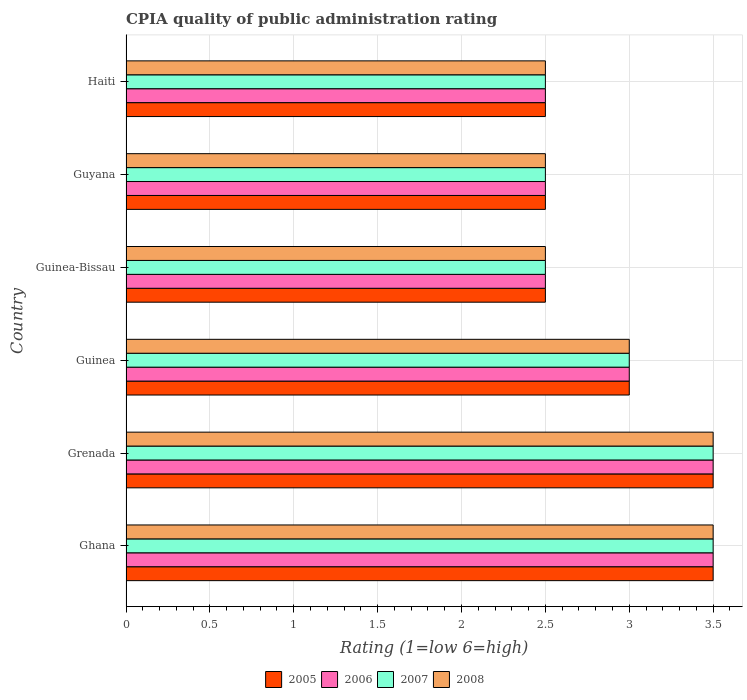How many different coloured bars are there?
Provide a short and direct response. 4. Are the number of bars on each tick of the Y-axis equal?
Your response must be concise. Yes. How many bars are there on the 1st tick from the bottom?
Provide a succinct answer. 4. What is the label of the 3rd group of bars from the top?
Make the answer very short. Guinea-Bissau. In how many cases, is the number of bars for a given country not equal to the number of legend labels?
Offer a terse response. 0. Across all countries, what is the maximum CPIA rating in 2008?
Give a very brief answer. 3.5. Across all countries, what is the minimum CPIA rating in 2007?
Offer a terse response. 2.5. In which country was the CPIA rating in 2007 maximum?
Keep it short and to the point. Ghana. In which country was the CPIA rating in 2008 minimum?
Ensure brevity in your answer.  Guinea-Bissau. What is the difference between the CPIA rating in 2007 in Ghana and the CPIA rating in 2008 in Guyana?
Offer a very short reply. 1. What is the average CPIA rating in 2005 per country?
Provide a short and direct response. 2.92. In how many countries, is the CPIA rating in 2005 greater than 2.2 ?
Offer a very short reply. 6. What is the ratio of the CPIA rating in 2006 in Ghana to that in Guinea-Bissau?
Provide a short and direct response. 1.4. Is the CPIA rating in 2007 in Grenada less than that in Guyana?
Your answer should be very brief. No. Is the difference between the CPIA rating in 2005 in Guyana and Haiti greater than the difference between the CPIA rating in 2006 in Guyana and Haiti?
Provide a succinct answer. No. What is the difference between the highest and the second highest CPIA rating in 2008?
Keep it short and to the point. 0. What is the difference between the highest and the lowest CPIA rating in 2008?
Keep it short and to the point. 1. Is it the case that in every country, the sum of the CPIA rating in 2005 and CPIA rating in 2008 is greater than the sum of CPIA rating in 2007 and CPIA rating in 2006?
Make the answer very short. No. What does the 4th bar from the top in Grenada represents?
Your answer should be very brief. 2005. What does the 4th bar from the bottom in Grenada represents?
Provide a short and direct response. 2008. Is it the case that in every country, the sum of the CPIA rating in 2005 and CPIA rating in 2006 is greater than the CPIA rating in 2008?
Ensure brevity in your answer.  Yes. How many bars are there?
Keep it short and to the point. 24. What is the difference between two consecutive major ticks on the X-axis?
Make the answer very short. 0.5. Does the graph contain grids?
Ensure brevity in your answer.  Yes. Where does the legend appear in the graph?
Give a very brief answer. Bottom center. How many legend labels are there?
Your response must be concise. 4. How are the legend labels stacked?
Keep it short and to the point. Horizontal. What is the title of the graph?
Your answer should be very brief. CPIA quality of public administration rating. Does "2005" appear as one of the legend labels in the graph?
Ensure brevity in your answer.  Yes. What is the label or title of the X-axis?
Ensure brevity in your answer.  Rating (1=low 6=high). What is the label or title of the Y-axis?
Offer a very short reply. Country. What is the Rating (1=low 6=high) of 2005 in Ghana?
Keep it short and to the point. 3.5. What is the Rating (1=low 6=high) in 2008 in Ghana?
Keep it short and to the point. 3.5. What is the Rating (1=low 6=high) in 2006 in Grenada?
Give a very brief answer. 3.5. What is the Rating (1=low 6=high) of 2008 in Guinea?
Offer a very short reply. 3. What is the Rating (1=low 6=high) in 2005 in Guinea-Bissau?
Provide a short and direct response. 2.5. What is the Rating (1=low 6=high) of 2006 in Guinea-Bissau?
Give a very brief answer. 2.5. What is the Rating (1=low 6=high) in 2007 in Guinea-Bissau?
Give a very brief answer. 2.5. What is the Rating (1=low 6=high) in 2006 in Guyana?
Make the answer very short. 2.5. What is the Rating (1=low 6=high) of 2008 in Guyana?
Offer a very short reply. 2.5. What is the Rating (1=low 6=high) in 2006 in Haiti?
Keep it short and to the point. 2.5. What is the Rating (1=low 6=high) in 2007 in Haiti?
Make the answer very short. 2.5. Across all countries, what is the maximum Rating (1=low 6=high) in 2006?
Your answer should be compact. 3.5. Across all countries, what is the maximum Rating (1=low 6=high) in 2008?
Make the answer very short. 3.5. Across all countries, what is the minimum Rating (1=low 6=high) in 2008?
Ensure brevity in your answer.  2.5. What is the total Rating (1=low 6=high) of 2005 in the graph?
Your response must be concise. 17.5. What is the total Rating (1=low 6=high) in 2007 in the graph?
Offer a terse response. 17.5. What is the total Rating (1=low 6=high) in 2008 in the graph?
Your answer should be very brief. 17.5. What is the difference between the Rating (1=low 6=high) in 2007 in Ghana and that in Grenada?
Offer a very short reply. 0. What is the difference between the Rating (1=low 6=high) of 2008 in Ghana and that in Grenada?
Keep it short and to the point. 0. What is the difference between the Rating (1=low 6=high) of 2005 in Ghana and that in Guinea?
Provide a short and direct response. 0.5. What is the difference between the Rating (1=low 6=high) in 2006 in Ghana and that in Guinea?
Your answer should be very brief. 0.5. What is the difference between the Rating (1=low 6=high) of 2005 in Ghana and that in Guinea-Bissau?
Give a very brief answer. 1. What is the difference between the Rating (1=low 6=high) of 2006 in Ghana and that in Guinea-Bissau?
Your response must be concise. 1. What is the difference between the Rating (1=low 6=high) in 2005 in Ghana and that in Guyana?
Make the answer very short. 1. What is the difference between the Rating (1=low 6=high) of 2006 in Ghana and that in Guyana?
Make the answer very short. 1. What is the difference between the Rating (1=low 6=high) of 2008 in Ghana and that in Guyana?
Keep it short and to the point. 1. What is the difference between the Rating (1=low 6=high) of 2006 in Ghana and that in Haiti?
Your answer should be compact. 1. What is the difference between the Rating (1=low 6=high) of 2008 in Ghana and that in Haiti?
Give a very brief answer. 1. What is the difference between the Rating (1=low 6=high) of 2005 in Grenada and that in Guinea?
Give a very brief answer. 0.5. What is the difference between the Rating (1=low 6=high) of 2007 in Grenada and that in Guinea-Bissau?
Ensure brevity in your answer.  1. What is the difference between the Rating (1=low 6=high) in 2008 in Grenada and that in Guyana?
Ensure brevity in your answer.  1. What is the difference between the Rating (1=low 6=high) in 2006 in Grenada and that in Haiti?
Offer a terse response. 1. What is the difference between the Rating (1=low 6=high) of 2005 in Guinea and that in Guinea-Bissau?
Provide a succinct answer. 0.5. What is the difference between the Rating (1=low 6=high) in 2006 in Guinea and that in Guyana?
Your response must be concise. 0.5. What is the difference between the Rating (1=low 6=high) of 2008 in Guinea and that in Guyana?
Your answer should be compact. 0.5. What is the difference between the Rating (1=low 6=high) in 2006 in Guinea and that in Haiti?
Your answer should be compact. 0.5. What is the difference between the Rating (1=low 6=high) in 2005 in Guinea-Bissau and that in Guyana?
Your answer should be very brief. 0. What is the difference between the Rating (1=low 6=high) of 2006 in Guinea-Bissau and that in Guyana?
Offer a terse response. 0. What is the difference between the Rating (1=low 6=high) of 2008 in Guinea-Bissau and that in Guyana?
Your answer should be very brief. 0. What is the difference between the Rating (1=low 6=high) in 2005 in Guinea-Bissau and that in Haiti?
Make the answer very short. 0. What is the difference between the Rating (1=low 6=high) in 2006 in Guinea-Bissau and that in Haiti?
Provide a succinct answer. 0. What is the difference between the Rating (1=low 6=high) in 2006 in Guyana and that in Haiti?
Your answer should be very brief. 0. What is the difference between the Rating (1=low 6=high) of 2007 in Guyana and that in Haiti?
Give a very brief answer. 0. What is the difference between the Rating (1=low 6=high) in 2008 in Guyana and that in Haiti?
Provide a succinct answer. 0. What is the difference between the Rating (1=low 6=high) in 2005 in Ghana and the Rating (1=low 6=high) in 2007 in Grenada?
Give a very brief answer. 0. What is the difference between the Rating (1=low 6=high) of 2005 in Ghana and the Rating (1=low 6=high) of 2008 in Grenada?
Offer a very short reply. 0. What is the difference between the Rating (1=low 6=high) of 2006 in Ghana and the Rating (1=low 6=high) of 2007 in Grenada?
Provide a short and direct response. 0. What is the difference between the Rating (1=low 6=high) of 2005 in Ghana and the Rating (1=low 6=high) of 2006 in Guinea?
Your answer should be very brief. 0.5. What is the difference between the Rating (1=low 6=high) of 2005 in Ghana and the Rating (1=low 6=high) of 2007 in Guinea?
Your answer should be compact. 0.5. What is the difference between the Rating (1=low 6=high) in 2005 in Ghana and the Rating (1=low 6=high) in 2008 in Guinea?
Your answer should be very brief. 0.5. What is the difference between the Rating (1=low 6=high) of 2006 in Ghana and the Rating (1=low 6=high) of 2007 in Guinea?
Ensure brevity in your answer.  0.5. What is the difference between the Rating (1=low 6=high) in 2006 in Ghana and the Rating (1=low 6=high) in 2008 in Guinea?
Give a very brief answer. 0.5. What is the difference between the Rating (1=low 6=high) of 2007 in Ghana and the Rating (1=low 6=high) of 2008 in Guinea?
Provide a short and direct response. 0.5. What is the difference between the Rating (1=low 6=high) of 2005 in Ghana and the Rating (1=low 6=high) of 2006 in Guinea-Bissau?
Ensure brevity in your answer.  1. What is the difference between the Rating (1=low 6=high) in 2005 in Ghana and the Rating (1=low 6=high) in 2006 in Guyana?
Keep it short and to the point. 1. What is the difference between the Rating (1=low 6=high) of 2005 in Ghana and the Rating (1=low 6=high) of 2007 in Guyana?
Offer a very short reply. 1. What is the difference between the Rating (1=low 6=high) in 2005 in Ghana and the Rating (1=low 6=high) in 2008 in Guyana?
Provide a succinct answer. 1. What is the difference between the Rating (1=low 6=high) of 2007 in Ghana and the Rating (1=low 6=high) of 2008 in Guyana?
Provide a short and direct response. 1. What is the difference between the Rating (1=low 6=high) in 2005 in Ghana and the Rating (1=low 6=high) in 2007 in Haiti?
Your answer should be compact. 1. What is the difference between the Rating (1=low 6=high) in 2005 in Ghana and the Rating (1=low 6=high) in 2008 in Haiti?
Provide a short and direct response. 1. What is the difference between the Rating (1=low 6=high) in 2006 in Ghana and the Rating (1=low 6=high) in 2007 in Haiti?
Give a very brief answer. 1. What is the difference between the Rating (1=low 6=high) in 2006 in Ghana and the Rating (1=low 6=high) in 2008 in Haiti?
Make the answer very short. 1. What is the difference between the Rating (1=low 6=high) of 2007 in Grenada and the Rating (1=low 6=high) of 2008 in Guinea?
Provide a succinct answer. 0.5. What is the difference between the Rating (1=low 6=high) of 2005 in Grenada and the Rating (1=low 6=high) of 2006 in Guinea-Bissau?
Offer a terse response. 1. What is the difference between the Rating (1=low 6=high) of 2007 in Grenada and the Rating (1=low 6=high) of 2008 in Guinea-Bissau?
Offer a very short reply. 1. What is the difference between the Rating (1=low 6=high) of 2005 in Grenada and the Rating (1=low 6=high) of 2006 in Guyana?
Keep it short and to the point. 1. What is the difference between the Rating (1=low 6=high) of 2007 in Grenada and the Rating (1=low 6=high) of 2008 in Guyana?
Provide a succinct answer. 1. What is the difference between the Rating (1=low 6=high) of 2005 in Grenada and the Rating (1=low 6=high) of 2006 in Haiti?
Provide a succinct answer. 1. What is the difference between the Rating (1=low 6=high) in 2005 in Grenada and the Rating (1=low 6=high) in 2008 in Haiti?
Ensure brevity in your answer.  1. What is the difference between the Rating (1=low 6=high) in 2007 in Grenada and the Rating (1=low 6=high) in 2008 in Haiti?
Offer a terse response. 1. What is the difference between the Rating (1=low 6=high) in 2005 in Guinea and the Rating (1=low 6=high) in 2008 in Guinea-Bissau?
Provide a short and direct response. 0.5. What is the difference between the Rating (1=low 6=high) in 2006 in Guinea and the Rating (1=low 6=high) in 2008 in Guinea-Bissau?
Provide a short and direct response. 0.5. What is the difference between the Rating (1=low 6=high) of 2005 in Guinea and the Rating (1=low 6=high) of 2006 in Guyana?
Your answer should be compact. 0.5. What is the difference between the Rating (1=low 6=high) in 2007 in Guinea and the Rating (1=low 6=high) in 2008 in Guyana?
Make the answer very short. 0.5. What is the difference between the Rating (1=low 6=high) of 2005 in Guinea and the Rating (1=low 6=high) of 2008 in Haiti?
Your answer should be compact. 0.5. What is the difference between the Rating (1=low 6=high) of 2006 in Guinea and the Rating (1=low 6=high) of 2008 in Haiti?
Provide a succinct answer. 0.5. What is the difference between the Rating (1=low 6=high) of 2005 in Guinea-Bissau and the Rating (1=low 6=high) of 2006 in Guyana?
Keep it short and to the point. 0. What is the difference between the Rating (1=low 6=high) of 2005 in Guinea-Bissau and the Rating (1=low 6=high) of 2007 in Guyana?
Provide a succinct answer. 0. What is the difference between the Rating (1=low 6=high) in 2005 in Guinea-Bissau and the Rating (1=low 6=high) in 2008 in Guyana?
Provide a short and direct response. 0. What is the difference between the Rating (1=low 6=high) of 2006 in Guinea-Bissau and the Rating (1=low 6=high) of 2007 in Guyana?
Make the answer very short. 0. What is the difference between the Rating (1=low 6=high) in 2006 in Guinea-Bissau and the Rating (1=low 6=high) in 2008 in Guyana?
Your answer should be very brief. 0. What is the difference between the Rating (1=low 6=high) of 2007 in Guinea-Bissau and the Rating (1=low 6=high) of 2008 in Guyana?
Your response must be concise. 0. What is the difference between the Rating (1=low 6=high) of 2005 in Guinea-Bissau and the Rating (1=low 6=high) of 2008 in Haiti?
Keep it short and to the point. 0. What is the difference between the Rating (1=low 6=high) in 2006 in Guinea-Bissau and the Rating (1=low 6=high) in 2007 in Haiti?
Make the answer very short. 0. What is the difference between the Rating (1=low 6=high) of 2007 in Guinea-Bissau and the Rating (1=low 6=high) of 2008 in Haiti?
Offer a terse response. 0. What is the difference between the Rating (1=low 6=high) in 2005 in Guyana and the Rating (1=low 6=high) in 2007 in Haiti?
Offer a terse response. 0. What is the difference between the Rating (1=low 6=high) in 2006 in Guyana and the Rating (1=low 6=high) in 2007 in Haiti?
Your answer should be compact. 0. What is the average Rating (1=low 6=high) in 2005 per country?
Provide a short and direct response. 2.92. What is the average Rating (1=low 6=high) in 2006 per country?
Keep it short and to the point. 2.92. What is the average Rating (1=low 6=high) of 2007 per country?
Provide a short and direct response. 2.92. What is the average Rating (1=low 6=high) of 2008 per country?
Give a very brief answer. 2.92. What is the difference between the Rating (1=low 6=high) of 2005 and Rating (1=low 6=high) of 2007 in Ghana?
Give a very brief answer. 0. What is the difference between the Rating (1=low 6=high) of 2005 and Rating (1=low 6=high) of 2008 in Ghana?
Provide a short and direct response. 0. What is the difference between the Rating (1=low 6=high) of 2005 and Rating (1=low 6=high) of 2007 in Grenada?
Ensure brevity in your answer.  0. What is the difference between the Rating (1=low 6=high) in 2005 and Rating (1=low 6=high) in 2008 in Grenada?
Your answer should be compact. 0. What is the difference between the Rating (1=low 6=high) of 2006 and Rating (1=low 6=high) of 2008 in Grenada?
Keep it short and to the point. 0. What is the difference between the Rating (1=low 6=high) in 2007 and Rating (1=low 6=high) in 2008 in Grenada?
Provide a short and direct response. 0. What is the difference between the Rating (1=low 6=high) in 2006 and Rating (1=low 6=high) in 2008 in Guinea?
Your answer should be compact. 0. What is the difference between the Rating (1=low 6=high) of 2005 and Rating (1=low 6=high) of 2006 in Guinea-Bissau?
Your response must be concise. 0. What is the difference between the Rating (1=low 6=high) of 2005 and Rating (1=low 6=high) of 2007 in Guinea-Bissau?
Ensure brevity in your answer.  0. What is the difference between the Rating (1=low 6=high) in 2007 and Rating (1=low 6=high) in 2008 in Guinea-Bissau?
Give a very brief answer. 0. What is the difference between the Rating (1=low 6=high) of 2005 and Rating (1=low 6=high) of 2006 in Guyana?
Your answer should be very brief. 0. What is the difference between the Rating (1=low 6=high) in 2006 and Rating (1=low 6=high) in 2007 in Guyana?
Your response must be concise. 0. What is the difference between the Rating (1=low 6=high) of 2006 and Rating (1=low 6=high) of 2008 in Guyana?
Give a very brief answer. 0. What is the difference between the Rating (1=low 6=high) of 2007 and Rating (1=low 6=high) of 2008 in Guyana?
Keep it short and to the point. 0. What is the difference between the Rating (1=low 6=high) of 2006 and Rating (1=low 6=high) of 2007 in Haiti?
Make the answer very short. 0. What is the ratio of the Rating (1=low 6=high) of 2005 in Ghana to that in Grenada?
Offer a very short reply. 1. What is the ratio of the Rating (1=low 6=high) of 2006 in Ghana to that in Grenada?
Provide a succinct answer. 1. What is the ratio of the Rating (1=low 6=high) in 2008 in Ghana to that in Grenada?
Provide a succinct answer. 1. What is the ratio of the Rating (1=low 6=high) of 2007 in Ghana to that in Guinea?
Ensure brevity in your answer.  1.17. What is the ratio of the Rating (1=low 6=high) of 2008 in Ghana to that in Guinea-Bissau?
Your answer should be compact. 1.4. What is the ratio of the Rating (1=low 6=high) in 2006 in Ghana to that in Guyana?
Offer a terse response. 1.4. What is the ratio of the Rating (1=low 6=high) in 2007 in Ghana to that in Guyana?
Provide a succinct answer. 1.4. What is the ratio of the Rating (1=low 6=high) of 2008 in Ghana to that in Guyana?
Ensure brevity in your answer.  1.4. What is the ratio of the Rating (1=low 6=high) in 2005 in Ghana to that in Haiti?
Ensure brevity in your answer.  1.4. What is the ratio of the Rating (1=low 6=high) of 2006 in Ghana to that in Haiti?
Offer a very short reply. 1.4. What is the ratio of the Rating (1=low 6=high) of 2006 in Grenada to that in Guinea?
Give a very brief answer. 1.17. What is the ratio of the Rating (1=low 6=high) in 2007 in Grenada to that in Guinea?
Offer a terse response. 1.17. What is the ratio of the Rating (1=low 6=high) of 2005 in Grenada to that in Guinea-Bissau?
Your response must be concise. 1.4. What is the ratio of the Rating (1=low 6=high) in 2006 in Grenada to that in Guinea-Bissau?
Provide a succinct answer. 1.4. What is the ratio of the Rating (1=low 6=high) of 2007 in Grenada to that in Guinea-Bissau?
Ensure brevity in your answer.  1.4. What is the ratio of the Rating (1=low 6=high) in 2008 in Grenada to that in Guinea-Bissau?
Offer a very short reply. 1.4. What is the ratio of the Rating (1=low 6=high) in 2005 in Grenada to that in Guyana?
Provide a short and direct response. 1.4. What is the ratio of the Rating (1=low 6=high) of 2006 in Grenada to that in Guyana?
Give a very brief answer. 1.4. What is the ratio of the Rating (1=low 6=high) of 2007 in Grenada to that in Guyana?
Make the answer very short. 1.4. What is the ratio of the Rating (1=low 6=high) in 2006 in Grenada to that in Haiti?
Make the answer very short. 1.4. What is the ratio of the Rating (1=low 6=high) in 2008 in Grenada to that in Haiti?
Your answer should be compact. 1.4. What is the ratio of the Rating (1=low 6=high) of 2006 in Guinea to that in Guinea-Bissau?
Give a very brief answer. 1.2. What is the ratio of the Rating (1=low 6=high) in 2005 in Guinea to that in Guyana?
Ensure brevity in your answer.  1.2. What is the ratio of the Rating (1=low 6=high) in 2006 in Guinea to that in Guyana?
Make the answer very short. 1.2. What is the ratio of the Rating (1=low 6=high) in 2008 in Guinea to that in Guyana?
Your answer should be compact. 1.2. What is the ratio of the Rating (1=low 6=high) of 2006 in Guinea to that in Haiti?
Provide a short and direct response. 1.2. What is the ratio of the Rating (1=low 6=high) in 2007 in Guinea to that in Haiti?
Give a very brief answer. 1.2. What is the ratio of the Rating (1=low 6=high) of 2008 in Guinea to that in Haiti?
Offer a terse response. 1.2. What is the ratio of the Rating (1=low 6=high) of 2006 in Guinea-Bissau to that in Guyana?
Your response must be concise. 1. What is the ratio of the Rating (1=low 6=high) of 2007 in Guinea-Bissau to that in Guyana?
Give a very brief answer. 1. What is the ratio of the Rating (1=low 6=high) in 2008 in Guinea-Bissau to that in Guyana?
Ensure brevity in your answer.  1. What is the ratio of the Rating (1=low 6=high) in 2006 in Guinea-Bissau to that in Haiti?
Keep it short and to the point. 1. What is the ratio of the Rating (1=low 6=high) of 2008 in Guinea-Bissau to that in Haiti?
Offer a terse response. 1. What is the difference between the highest and the second highest Rating (1=low 6=high) in 2006?
Make the answer very short. 0. What is the difference between the highest and the lowest Rating (1=low 6=high) of 2006?
Your answer should be very brief. 1. What is the difference between the highest and the lowest Rating (1=low 6=high) of 2007?
Offer a terse response. 1. 